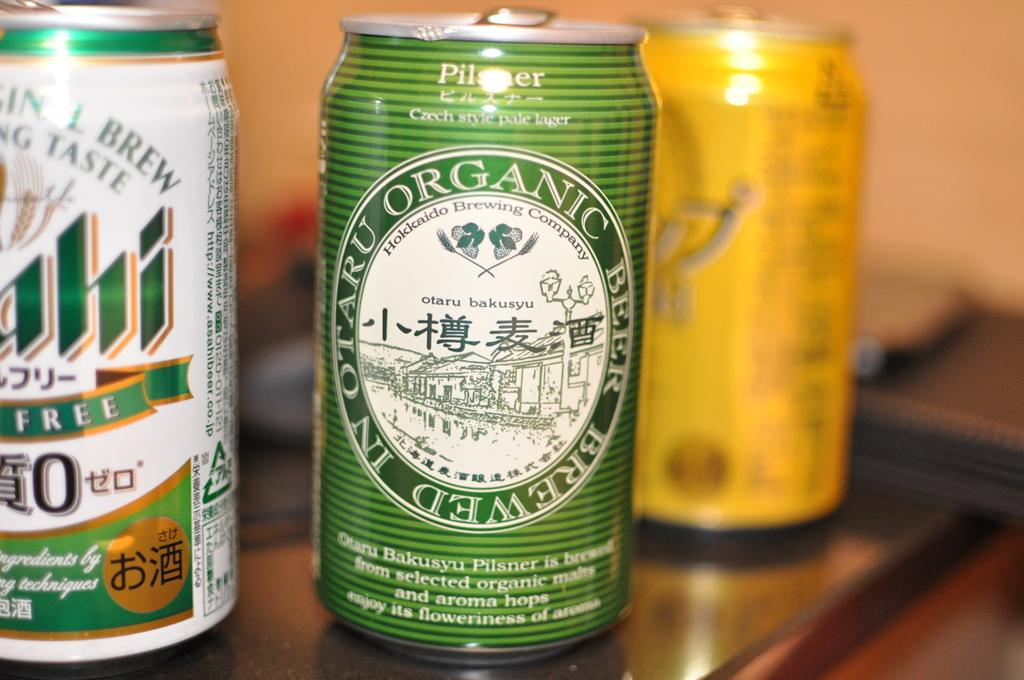<image>
Summarize the visual content of the image. Several cans of beer, the one in the middle is organic. 